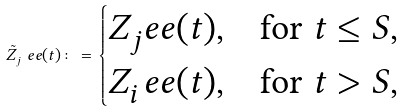Convert formula to latex. <formula><loc_0><loc_0><loc_500><loc_500>\tilde { Z } _ { j } ^ { \ } e e ( t ) \colon = \begin{cases} Z _ { j } ^ { \ } e e ( t ) , & \text {for $t \leq S$} , \\ Z _ { i } ^ { \ } e e ( t ) , & \text {for $t > S$} , \\ \end{cases}</formula> 